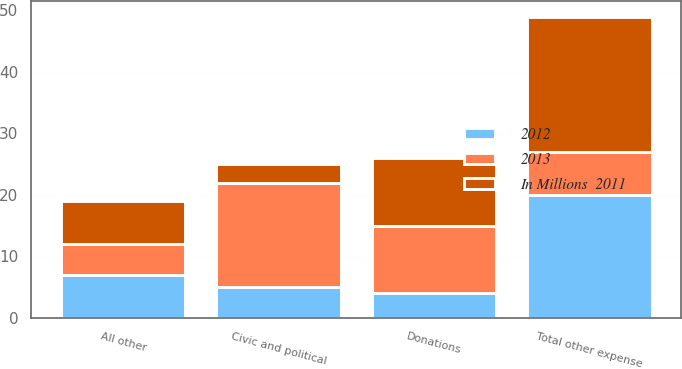Convert chart. <chart><loc_0><loc_0><loc_500><loc_500><stacked_bar_chart><ecel><fcel>Donations<fcel>Civic and political<fcel>All other<fcel>Total other expense<nl><fcel>2012<fcel>4<fcel>5<fcel>7<fcel>20<nl><fcel>2013<fcel>11<fcel>17<fcel>5<fcel>7<nl><fcel>In Millions  2011<fcel>11<fcel>3<fcel>7<fcel>22<nl></chart> 